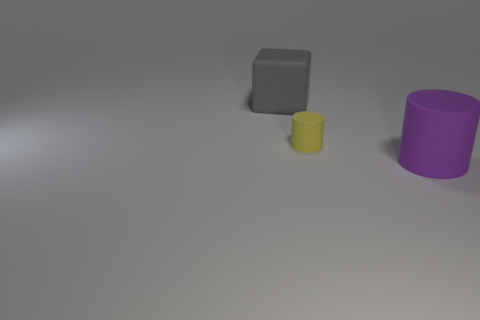How many other objects are the same shape as the yellow rubber thing?
Keep it short and to the point. 1. Is the shape of the tiny thing the same as the large gray rubber thing?
Your answer should be very brief. No. There is a small rubber object; are there any gray objects on the left side of it?
Offer a very short reply. Yes. What number of things are either tiny purple metallic cubes or large purple cylinders?
Your response must be concise. 1. How many other objects are the same size as the gray thing?
Give a very brief answer. 1. How many rubber objects are both on the left side of the big purple matte object and to the right of the large cube?
Provide a succinct answer. 1. Does the matte object right of the yellow rubber thing have the same size as the matte cylinder on the left side of the large rubber cylinder?
Offer a very short reply. No. There is a gray matte block that is behind the large purple cylinder; how big is it?
Offer a very short reply. Large. How many things are either large rubber things that are to the right of the big gray object or big rubber objects that are to the right of the gray rubber object?
Provide a short and direct response. 1. Are there an equal number of purple things that are left of the gray matte object and small things behind the tiny object?
Your response must be concise. Yes. 